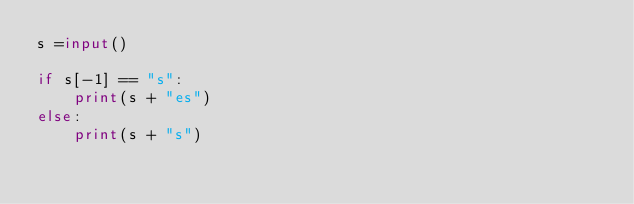Convert code to text. <code><loc_0><loc_0><loc_500><loc_500><_Python_>s =input()

if s[-1] == "s":
    print(s + "es")
else:
    print(s + "s")</code> 